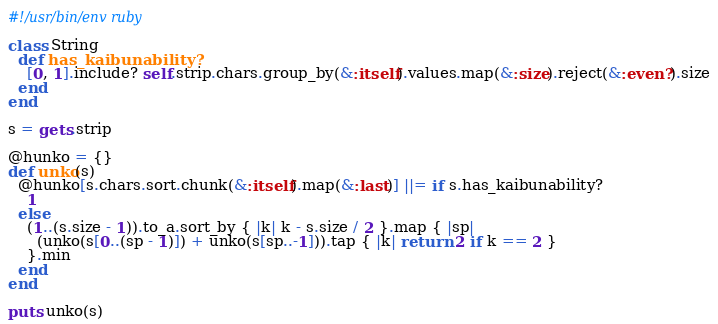<code> <loc_0><loc_0><loc_500><loc_500><_Ruby_>#!/usr/bin/env ruby

class String
  def has_kaibunability?
    [0, 1].include? self.strip.chars.group_by(&:itself).values.map(&:size).reject(&:even?).size
  end
end

s = gets.strip

@hunko = {}
def unko(s)
  @hunko[s.chars.sort.chunk(&:itself).map(&:last)] ||= if s.has_kaibunability?
    1
  else
    (1..(s.size - 1)).to_a.sort_by { |k| k - s.size / 2 }.map { |sp|
      (unko(s[0..(sp - 1)]) + unko(s[sp..-1])).tap { |k| return 2 if k == 2 }
    }.min
  end
end

puts unko(s)
</code> 